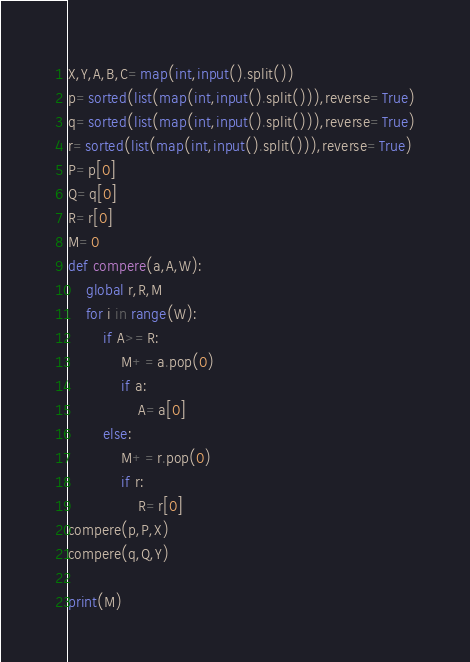Convert code to text. <code><loc_0><loc_0><loc_500><loc_500><_Python_>X,Y,A,B,C=map(int,input().split())
p=sorted(list(map(int,input().split())),reverse=True)
q=sorted(list(map(int,input().split())),reverse=True)
r=sorted(list(map(int,input().split())),reverse=True)
P=p[0]
Q=q[0]
R=r[0]
M=0
def compere(a,A,W):
    global r,R,M
    for i in range(W):
        if A>=R:
            M+=a.pop(0)
            if a:
                A=a[0]
        else:
            M+=r.pop(0)
            if r:
                R=r[0]
compere(p,P,X)
compere(q,Q,Y)

print(M)
</code> 